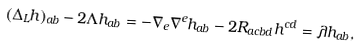<formula> <loc_0><loc_0><loc_500><loc_500>( \Delta _ { L } h ) _ { a b } - 2 \Lambda h _ { a b } = - \nabla _ { e } \nabla ^ { e } h _ { a b } - 2 R _ { a c b d } h ^ { c d } = \lambda h _ { a b } ,</formula> 